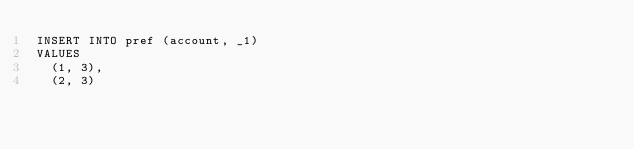<code> <loc_0><loc_0><loc_500><loc_500><_SQL_>INSERT INTO pref (account, _1)
VALUES
  (1, 3),
  (2, 3)</code> 